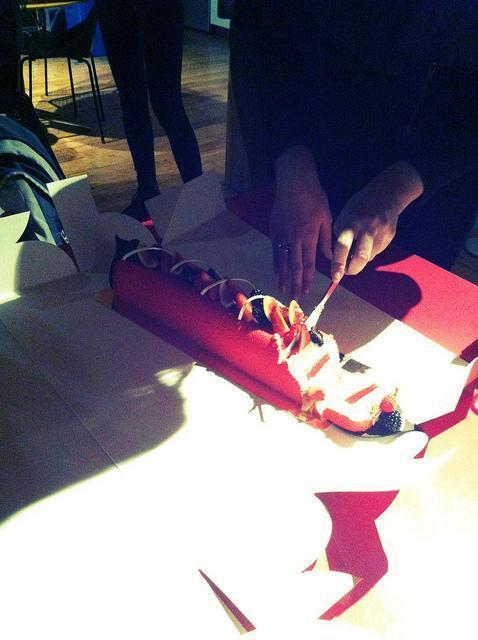How many people are there?
Give a very brief answer. 2. 